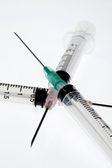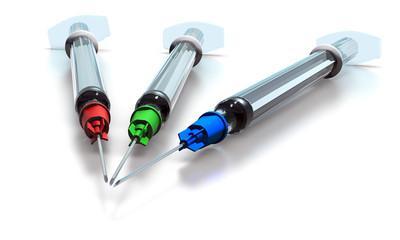The first image is the image on the left, the second image is the image on the right. Considering the images on both sides, is "An image includes syringes with green, red, and blue components." valid? Answer yes or no. Yes. The first image is the image on the left, the second image is the image on the right. For the images shown, is this caption "Three syringes lie on a surface near each other in the image on the left." true? Answer yes or no. Yes. 